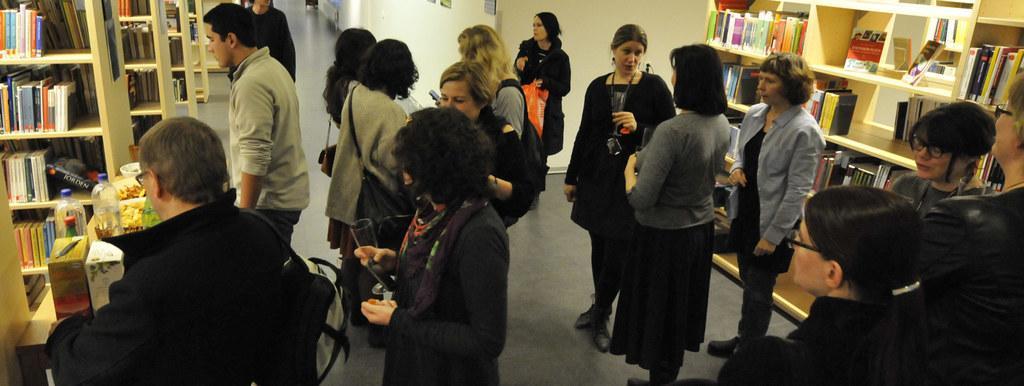Please provide a concise description of this image. In this image I can see the group of people with different color dresses. I can see few people are holding the glasses. To the side of these people I can see the rack with many books. To the left I can see the bottles, box, bowls and plates with food. These are on the table. 